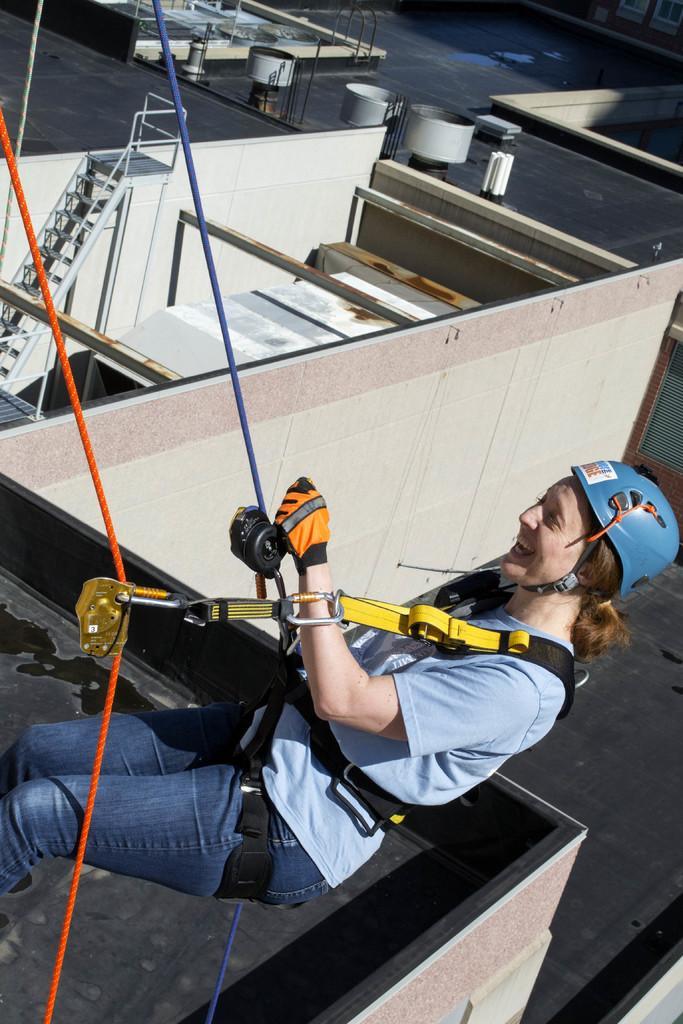Describe this image in one or two sentences. In this image I can see a person on the ropes. She is wearing blue top and jeans and blue helmet. Background I can see a building,some objects on the terrace and stairs. 